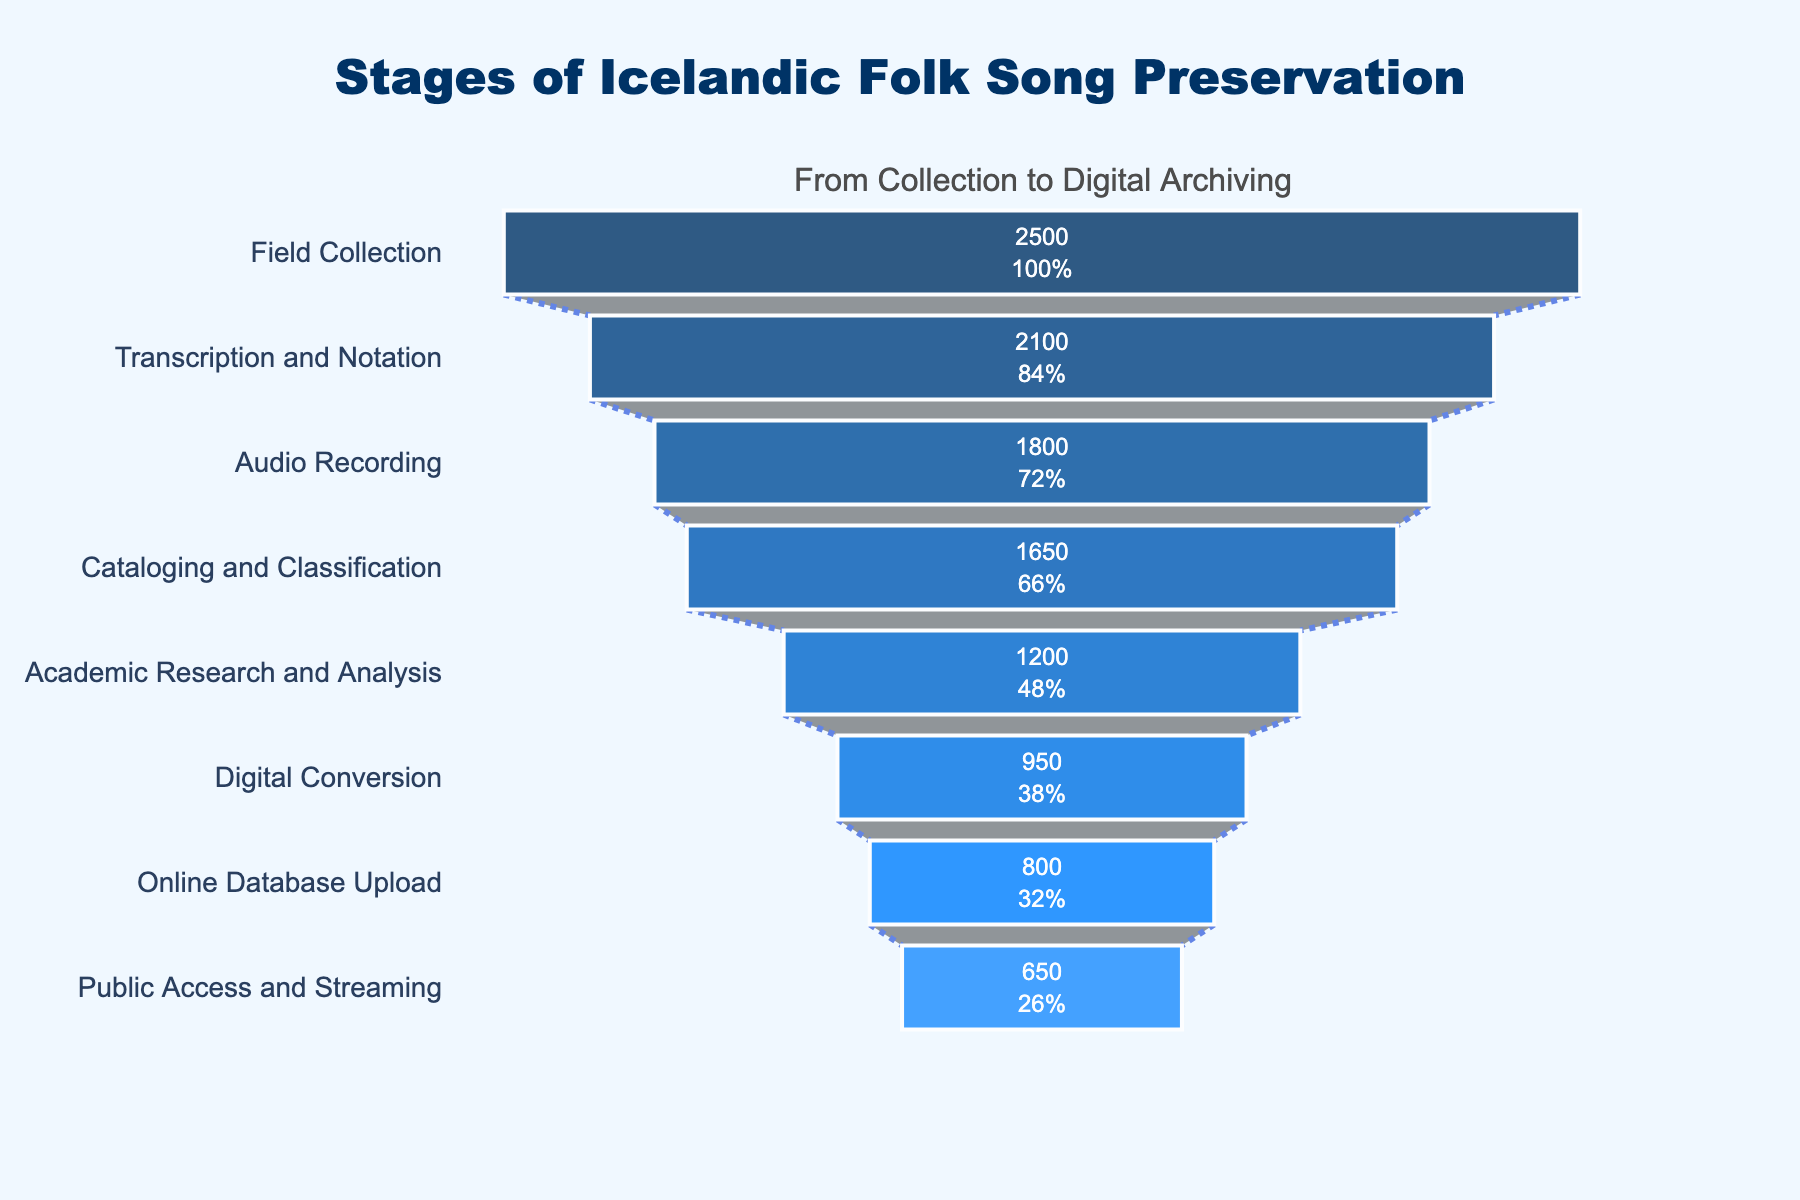What is the title of the funnel chart? The title is displayed at the top of the chart. It summarizes the overall focus of the chart.
Answer: Stages of Icelandic Folk Song Preservation How many stages are there in the preservation process? Count the number of unique stages listed on the y-axis of the chart.
Answer: 8 Which stage has the highest number of preserved songs? Identify the stage with the longest bar at the widest section of the funnel.
Answer: Field Collection What is the percentage of songs that move from "Field Collection" to "Transcription and Notation"? Calculate the percentage by dividing the number of songs in "Transcription and Notation" by the number of songs in "Field Collection" and multiplying by 100.
Answer: 84% What's the total number of songs at the "Academic Research and Analysis" and "Digital Conversion" stages combined? Add the number of songs from both stages. 1200 (Academic Research and Analysis) + 950 (Digital Conversion) = 2150
Answer: 2150 Which stage has the least number of preserved songs? Identify the stage with the shortest bar at the narrowest section of the funnel.
Answer: Public Access and Streaming By how much does the number of songs decrease from "Cataloging and Classification" to "Academic Research and Analysis"? Subtract the number of songs at "Academic Research and Analysis" from the number of songs at "Cataloging and Classification". 1650 - 1200 = 450
Answer: 450 What fraction of the songs initially collected make it to the "Online Database Upload" stage? Divide the number of songs at "Online Database Upload" by the number of songs at "Field Collection".
Answer: 800/2500 Which two stages have the closest number of songs? Find two consecutive or non-consecutive stages with the smallest numerical difference in the number of songs.
Answer: Digital Conversion and Online Database Upload What is the percentage decrease in the number of songs from "Field Collection" to "Public Access and Streaming"? Calculate the percentage decrease by subtracting the number of songs at "Public Access and Streaming" from "Field Collection", dividing by the number of songs at "Field Collection", and then multiplying by 100: ((2500 - 650) / 2500) * 100.
Answer: 74% 